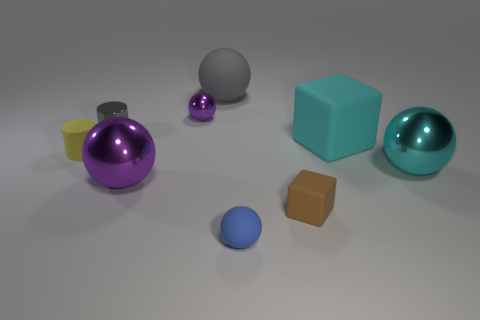Is the number of rubber objects greater than the number of cyan spheres?
Make the answer very short. Yes. There is a yellow cylinder that is the same material as the brown block; what size is it?
Keep it short and to the point. Small. There is a gray thing that is left of the gray sphere; is it the same size as the purple object that is behind the large cyan metal sphere?
Offer a very short reply. Yes. How many things are metal things left of the blue matte thing or purple things?
Your answer should be very brief. 3. Is the number of large rubber spheres less than the number of tiny shiny objects?
Make the answer very short. Yes. What is the shape of the small rubber thing that is behind the block that is in front of the metal object that is on the right side of the big gray rubber ball?
Your answer should be compact. Cylinder. What is the shape of the object that is the same color as the large rubber sphere?
Your answer should be compact. Cylinder. Are any brown blocks visible?
Provide a short and direct response. Yes. Do the brown object and the shiny object that is on the right side of the large rubber block have the same size?
Your answer should be compact. No. There is a large ball behind the tiny yellow matte thing; is there a big purple metal ball behind it?
Ensure brevity in your answer.  No. 